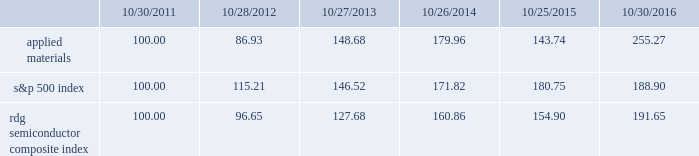Performance graph the performance graph below shows the five-year cumulative total stockholder return on applied common stock during the period from october 30 , 2011 through october 30 , 2016 .
This is compared with the cumulative total return of the standard & poor 2019s 500 stock index and the rdg semiconductor composite index over the same period .
The comparison assumes $ 100 was invested on october 30 , 2011 in applied common stock and in each of the foregoing indices and assumes reinvestment of dividends , if any .
Dollar amounts in the graph are rounded to the nearest whole dollar .
The performance shown in the graph represents past performance and should not be considered an indication of future performance .
Comparison of 5 year cumulative total return* among applied materials , inc. , the s&p 500 index and the rdg semiconductor composite index *assumes $ 100 invested on 10/30/11 in stock or 10/31/11 in index , including reinvestment of dividends .
Indexes calculated on month-end basis .
Copyright a9 2016 standard & poor 2019s , a division of s&p global .
All rights reserved. .
Dividends during each of fiscal 2016 , 2015 , and 2014 , applied 2019s board of directors declared four quarterly cash dividends in the amount of $ 0.10 per share .
Applied currently anticipates that cash dividends will continue to be paid on a quarterly basis , although the declaration of any future cash dividend is at the discretion of the board of directors and will depend on applied 2019s financial condition , results of operations , capital requirements , business conditions and other factors , as well as a determination by the board of directors that cash dividends are in the best interests of applied 2019s stockholders .
10/30/11 10/28/12 10/27/13 10/26/14 10/25/15 10/30/16 applied materials , inc .
S&p 500 rdg semiconductor composite .
What is the total return if 1000000 is invested in s&p500 in 2011 and sold in 2012? 
Computations: ((1000000 / 100) * (115.21 - 100))
Answer: 152100.0. 